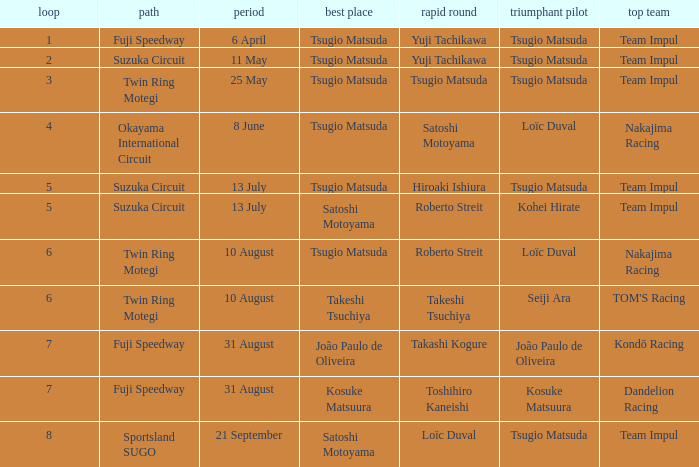What is the fastest lap for Seiji Ara? Takeshi Tsuchiya. 